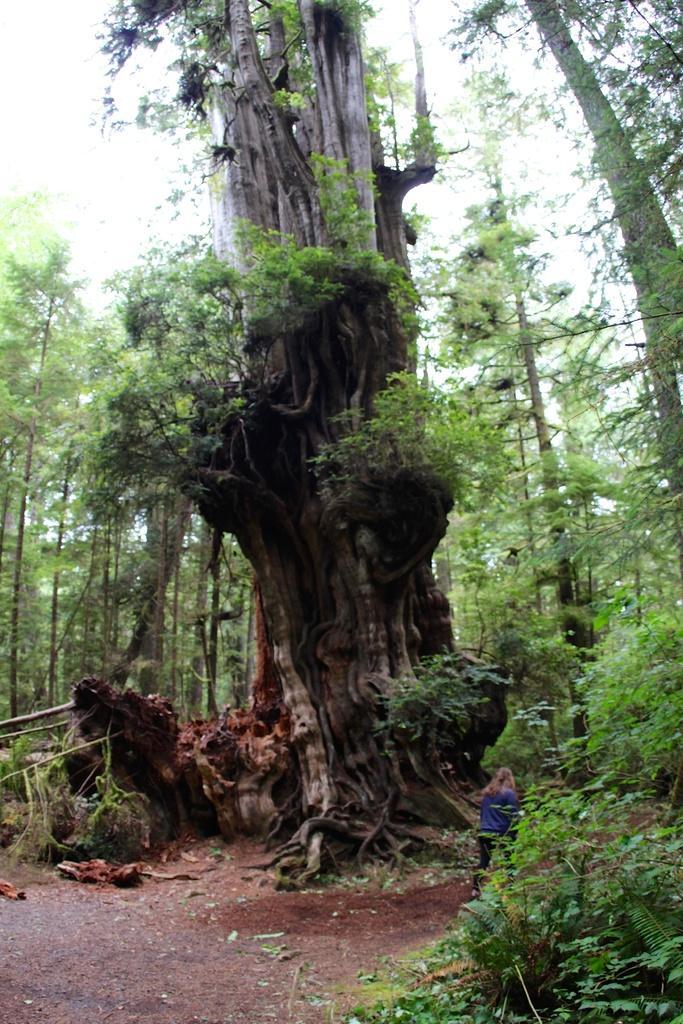In one or two sentences, can you explain what this image depicts? This picture is clicked outside the city. On the right we can see the plants and a person seems to be walking on the ground. In the background we can see the sky, trees and in the center we can see the trunks of the trees. 